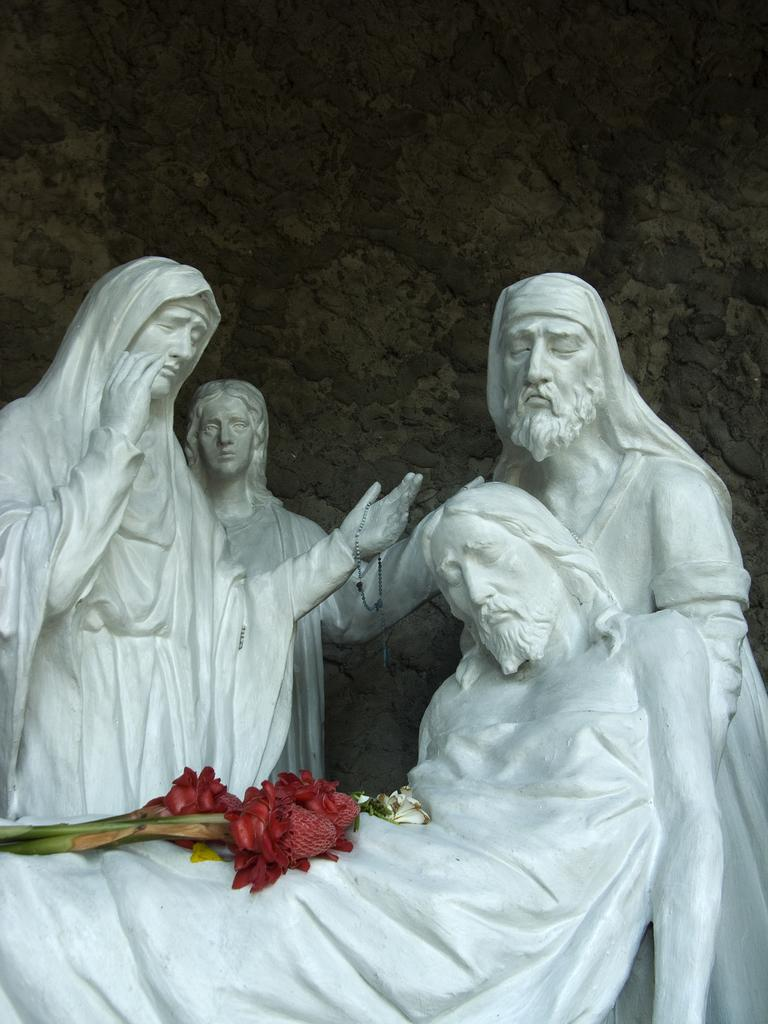What material is used to create the sculptures in the image? The sculptures in the image are made up of rock. What color are the sculptures? The sculptures are in white color. What design elements are present on the sculptures? Flowers are depicted on the sculptures. What can be seen in the background of the image? There is a rock visible in the background of the image. What is the temperature of the sculptures in the image? The temperature of the sculptures cannot be determined from the image, as they are made of rock and not a substance that can have a temperature. 